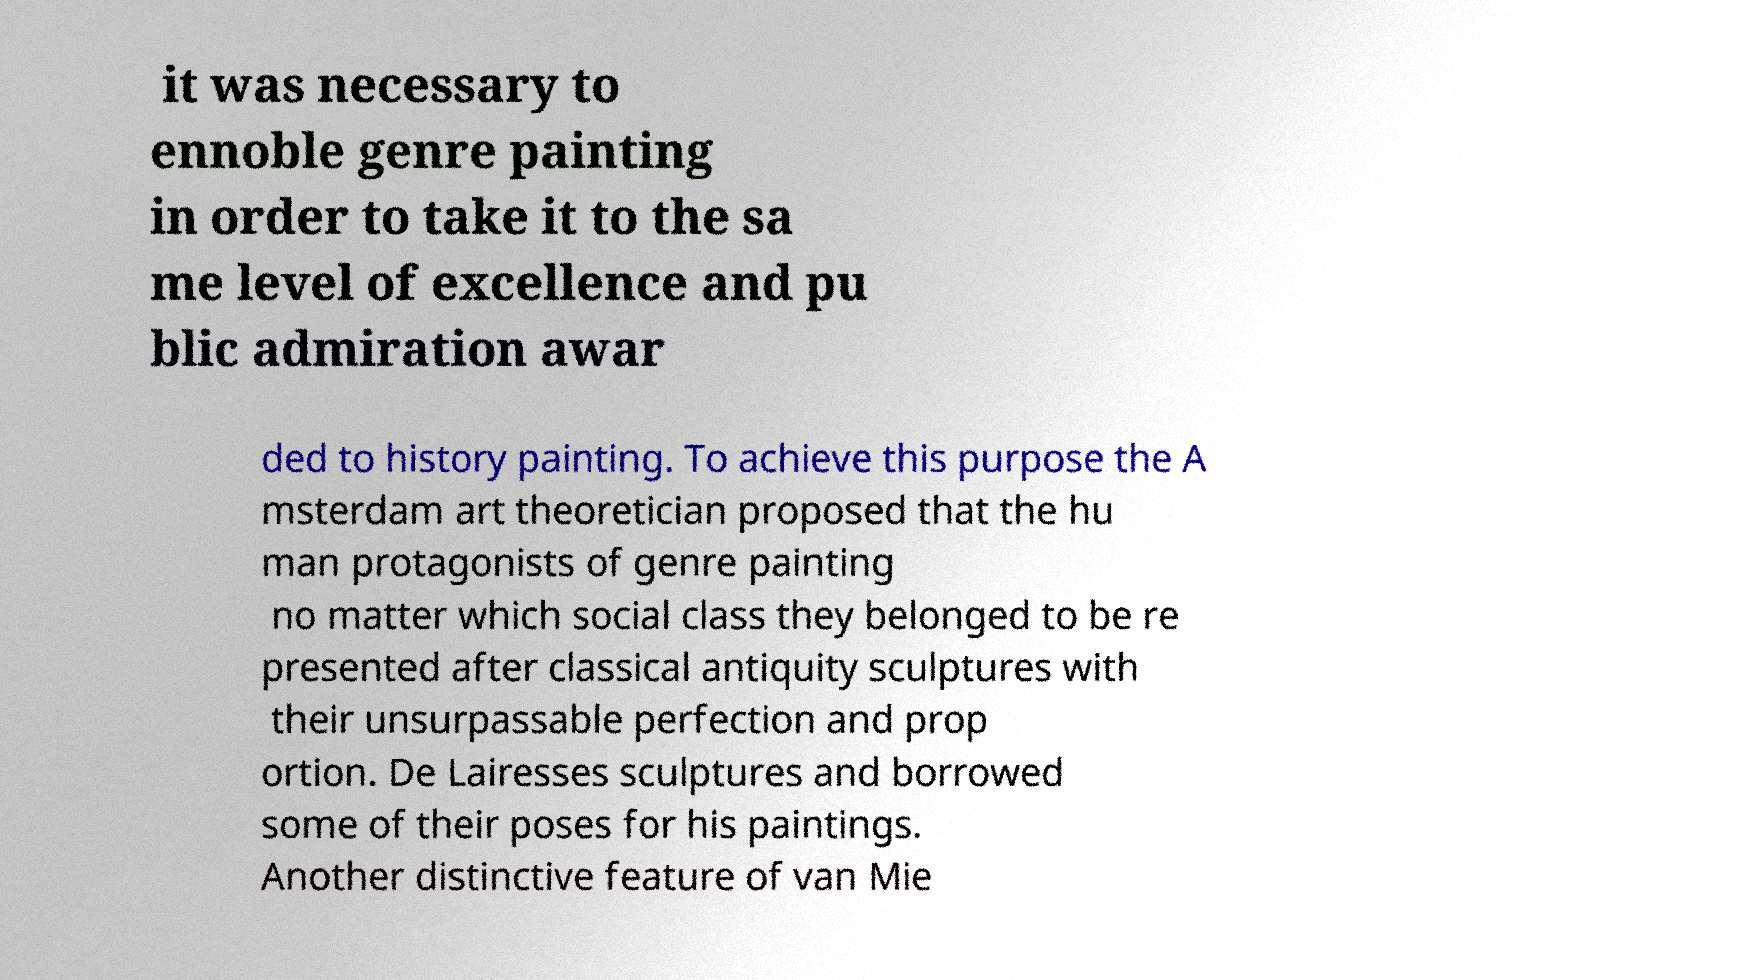Can you read and provide the text displayed in the image?This photo seems to have some interesting text. Can you extract and type it out for me? it was necessary to ennoble genre painting in order to take it to the sa me level of excellence and pu blic admiration awar ded to history painting. To achieve this purpose the A msterdam art theoretician proposed that the hu man protagonists of genre painting no matter which social class they belonged to be re presented after classical antiquity sculptures with their unsurpassable perfection and prop ortion. De Lairesses sculptures and borrowed some of their poses for his paintings. Another distinctive feature of van Mie 